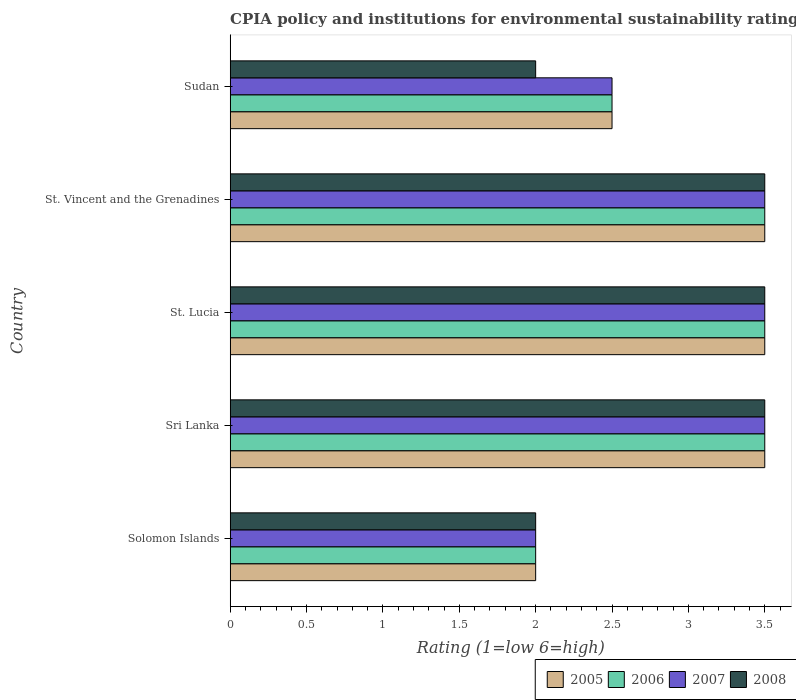How many different coloured bars are there?
Offer a terse response. 4. How many groups of bars are there?
Make the answer very short. 5. Are the number of bars on each tick of the Y-axis equal?
Ensure brevity in your answer.  Yes. How many bars are there on the 2nd tick from the top?
Keep it short and to the point. 4. What is the label of the 3rd group of bars from the top?
Your answer should be very brief. St. Lucia. In how many cases, is the number of bars for a given country not equal to the number of legend labels?
Your response must be concise. 0. What is the CPIA rating in 2007 in Sri Lanka?
Make the answer very short. 3.5. Across all countries, what is the minimum CPIA rating in 2005?
Your answer should be very brief. 2. In which country was the CPIA rating in 2005 maximum?
Provide a short and direct response. Sri Lanka. In which country was the CPIA rating in 2006 minimum?
Provide a succinct answer. Solomon Islands. What is the total CPIA rating in 2008 in the graph?
Provide a short and direct response. 14.5. What is the difference between the CPIA rating in 2007 in Sri Lanka and that in St. Lucia?
Keep it short and to the point. 0. What is the difference between the CPIA rating in 2008 in St. Lucia and the CPIA rating in 2006 in Sri Lanka?
Ensure brevity in your answer.  0. What is the difference between the CPIA rating in 2007 and CPIA rating in 2008 in Sri Lanka?
Give a very brief answer. 0. In how many countries, is the CPIA rating in 2005 greater than 3 ?
Make the answer very short. 3. Is the CPIA rating in 2005 in Sri Lanka less than that in Sudan?
Your answer should be compact. No. What is the difference between the highest and the second highest CPIA rating in 2008?
Your response must be concise. 0. What is the difference between the highest and the lowest CPIA rating in 2008?
Provide a succinct answer. 1.5. Is the sum of the CPIA rating in 2006 in Solomon Islands and Sri Lanka greater than the maximum CPIA rating in 2008 across all countries?
Give a very brief answer. Yes. Is it the case that in every country, the sum of the CPIA rating in 2005 and CPIA rating in 2008 is greater than the sum of CPIA rating in 2006 and CPIA rating in 2007?
Keep it short and to the point. No. What does the 2nd bar from the top in Sri Lanka represents?
Ensure brevity in your answer.  2007. What does the 4th bar from the bottom in St. Vincent and the Grenadines represents?
Offer a very short reply. 2008. Is it the case that in every country, the sum of the CPIA rating in 2008 and CPIA rating in 2006 is greater than the CPIA rating in 2007?
Give a very brief answer. Yes. How many bars are there?
Provide a succinct answer. 20. Are all the bars in the graph horizontal?
Make the answer very short. Yes. What is the difference between two consecutive major ticks on the X-axis?
Give a very brief answer. 0.5. Does the graph contain any zero values?
Your answer should be very brief. No. Where does the legend appear in the graph?
Offer a very short reply. Bottom right. How many legend labels are there?
Provide a succinct answer. 4. What is the title of the graph?
Ensure brevity in your answer.  CPIA policy and institutions for environmental sustainability rating. What is the label or title of the X-axis?
Make the answer very short. Rating (1=low 6=high). What is the Rating (1=low 6=high) in 2006 in Solomon Islands?
Make the answer very short. 2. What is the Rating (1=low 6=high) in 2005 in Sri Lanka?
Offer a very short reply. 3.5. What is the Rating (1=low 6=high) in 2006 in Sri Lanka?
Your answer should be very brief. 3.5. What is the Rating (1=low 6=high) of 2005 in St. Vincent and the Grenadines?
Offer a terse response. 3.5. What is the Rating (1=low 6=high) of 2006 in St. Vincent and the Grenadines?
Give a very brief answer. 3.5. What is the Rating (1=low 6=high) in 2005 in Sudan?
Provide a short and direct response. 2.5. What is the Rating (1=low 6=high) in 2006 in Sudan?
Offer a terse response. 2.5. What is the Rating (1=low 6=high) of 2007 in Sudan?
Your response must be concise. 2.5. What is the Rating (1=low 6=high) in 2008 in Sudan?
Offer a very short reply. 2. Across all countries, what is the maximum Rating (1=low 6=high) of 2006?
Give a very brief answer. 3.5. Across all countries, what is the maximum Rating (1=low 6=high) in 2007?
Offer a very short reply. 3.5. Across all countries, what is the maximum Rating (1=low 6=high) in 2008?
Provide a succinct answer. 3.5. Across all countries, what is the minimum Rating (1=low 6=high) in 2005?
Your answer should be very brief. 2. What is the total Rating (1=low 6=high) in 2007 in the graph?
Make the answer very short. 15. What is the difference between the Rating (1=low 6=high) of 2005 in Solomon Islands and that in Sri Lanka?
Your answer should be compact. -1.5. What is the difference between the Rating (1=low 6=high) in 2006 in Solomon Islands and that in Sri Lanka?
Offer a very short reply. -1.5. What is the difference between the Rating (1=low 6=high) in 2008 in Solomon Islands and that in St. Lucia?
Your answer should be very brief. -1.5. What is the difference between the Rating (1=low 6=high) in 2005 in Solomon Islands and that in St. Vincent and the Grenadines?
Give a very brief answer. -1.5. What is the difference between the Rating (1=low 6=high) in 2007 in Solomon Islands and that in St. Vincent and the Grenadines?
Give a very brief answer. -1.5. What is the difference between the Rating (1=low 6=high) in 2008 in Solomon Islands and that in St. Vincent and the Grenadines?
Offer a very short reply. -1.5. What is the difference between the Rating (1=low 6=high) of 2008 in Solomon Islands and that in Sudan?
Provide a succinct answer. 0. What is the difference between the Rating (1=low 6=high) of 2005 in Sri Lanka and that in St. Lucia?
Give a very brief answer. 0. What is the difference between the Rating (1=low 6=high) in 2007 in Sri Lanka and that in St. Lucia?
Keep it short and to the point. 0. What is the difference between the Rating (1=low 6=high) of 2007 in Sri Lanka and that in St. Vincent and the Grenadines?
Provide a succinct answer. 0. What is the difference between the Rating (1=low 6=high) of 2008 in Sri Lanka and that in St. Vincent and the Grenadines?
Your answer should be compact. 0. What is the difference between the Rating (1=low 6=high) of 2005 in Sri Lanka and that in Sudan?
Your answer should be compact. 1. What is the difference between the Rating (1=low 6=high) in 2006 in Sri Lanka and that in Sudan?
Provide a succinct answer. 1. What is the difference between the Rating (1=low 6=high) in 2008 in Sri Lanka and that in Sudan?
Make the answer very short. 1.5. What is the difference between the Rating (1=low 6=high) of 2005 in St. Lucia and that in St. Vincent and the Grenadines?
Your response must be concise. 0. What is the difference between the Rating (1=low 6=high) of 2007 in St. Lucia and that in St. Vincent and the Grenadines?
Provide a short and direct response. 0. What is the difference between the Rating (1=low 6=high) of 2005 in St. Lucia and that in Sudan?
Ensure brevity in your answer.  1. What is the difference between the Rating (1=low 6=high) in 2006 in St. Vincent and the Grenadines and that in Sudan?
Make the answer very short. 1. What is the difference between the Rating (1=low 6=high) of 2005 in Solomon Islands and the Rating (1=low 6=high) of 2006 in Sri Lanka?
Your response must be concise. -1.5. What is the difference between the Rating (1=low 6=high) of 2006 in Solomon Islands and the Rating (1=low 6=high) of 2008 in Sri Lanka?
Offer a terse response. -1.5. What is the difference between the Rating (1=low 6=high) of 2005 in Solomon Islands and the Rating (1=low 6=high) of 2007 in St. Lucia?
Your response must be concise. -1.5. What is the difference between the Rating (1=low 6=high) in 2005 in Solomon Islands and the Rating (1=low 6=high) in 2008 in St. Lucia?
Provide a short and direct response. -1.5. What is the difference between the Rating (1=low 6=high) in 2007 in Solomon Islands and the Rating (1=low 6=high) in 2008 in St. Lucia?
Your answer should be very brief. -1.5. What is the difference between the Rating (1=low 6=high) in 2005 in Solomon Islands and the Rating (1=low 6=high) in 2006 in St. Vincent and the Grenadines?
Make the answer very short. -1.5. What is the difference between the Rating (1=low 6=high) of 2005 in Solomon Islands and the Rating (1=low 6=high) of 2007 in St. Vincent and the Grenadines?
Offer a very short reply. -1.5. What is the difference between the Rating (1=low 6=high) of 2006 in Solomon Islands and the Rating (1=low 6=high) of 2007 in St. Vincent and the Grenadines?
Your answer should be compact. -1.5. What is the difference between the Rating (1=low 6=high) in 2006 in Solomon Islands and the Rating (1=low 6=high) in 2007 in Sudan?
Make the answer very short. -0.5. What is the difference between the Rating (1=low 6=high) of 2007 in Solomon Islands and the Rating (1=low 6=high) of 2008 in Sudan?
Ensure brevity in your answer.  0. What is the difference between the Rating (1=low 6=high) of 2005 in Sri Lanka and the Rating (1=low 6=high) of 2006 in St. Lucia?
Provide a succinct answer. 0. What is the difference between the Rating (1=low 6=high) of 2006 in Sri Lanka and the Rating (1=low 6=high) of 2008 in St. Lucia?
Provide a short and direct response. 0. What is the difference between the Rating (1=low 6=high) in 2007 in Sri Lanka and the Rating (1=low 6=high) in 2008 in St. Lucia?
Ensure brevity in your answer.  0. What is the difference between the Rating (1=low 6=high) of 2005 in Sri Lanka and the Rating (1=low 6=high) of 2006 in St. Vincent and the Grenadines?
Offer a very short reply. 0. What is the difference between the Rating (1=low 6=high) of 2005 in Sri Lanka and the Rating (1=low 6=high) of 2007 in St. Vincent and the Grenadines?
Provide a short and direct response. 0. What is the difference between the Rating (1=low 6=high) of 2005 in Sri Lanka and the Rating (1=low 6=high) of 2008 in St. Vincent and the Grenadines?
Provide a succinct answer. 0. What is the difference between the Rating (1=low 6=high) in 2006 in Sri Lanka and the Rating (1=low 6=high) in 2007 in St. Vincent and the Grenadines?
Offer a very short reply. 0. What is the difference between the Rating (1=low 6=high) of 2007 in Sri Lanka and the Rating (1=low 6=high) of 2008 in St. Vincent and the Grenadines?
Ensure brevity in your answer.  0. What is the difference between the Rating (1=low 6=high) in 2005 in Sri Lanka and the Rating (1=low 6=high) in 2008 in Sudan?
Provide a short and direct response. 1.5. What is the difference between the Rating (1=low 6=high) in 2005 in St. Lucia and the Rating (1=low 6=high) in 2006 in St. Vincent and the Grenadines?
Your answer should be very brief. 0. What is the difference between the Rating (1=low 6=high) in 2006 in St. Lucia and the Rating (1=low 6=high) in 2007 in St. Vincent and the Grenadines?
Offer a terse response. 0. What is the difference between the Rating (1=low 6=high) of 2006 in St. Lucia and the Rating (1=low 6=high) of 2007 in Sudan?
Offer a very short reply. 1. What is the difference between the Rating (1=low 6=high) in 2005 in St. Vincent and the Grenadines and the Rating (1=low 6=high) in 2007 in Sudan?
Keep it short and to the point. 1. What is the difference between the Rating (1=low 6=high) of 2005 in St. Vincent and the Grenadines and the Rating (1=low 6=high) of 2008 in Sudan?
Provide a succinct answer. 1.5. What is the average Rating (1=low 6=high) in 2006 per country?
Give a very brief answer. 3. What is the average Rating (1=low 6=high) of 2007 per country?
Your answer should be compact. 3. What is the difference between the Rating (1=low 6=high) in 2005 and Rating (1=low 6=high) in 2006 in Solomon Islands?
Make the answer very short. 0. What is the difference between the Rating (1=low 6=high) of 2005 and Rating (1=low 6=high) of 2007 in Solomon Islands?
Make the answer very short. 0. What is the difference between the Rating (1=low 6=high) in 2005 and Rating (1=low 6=high) in 2008 in Solomon Islands?
Keep it short and to the point. 0. What is the difference between the Rating (1=low 6=high) in 2005 and Rating (1=low 6=high) in 2007 in Sri Lanka?
Your answer should be compact. 0. What is the difference between the Rating (1=low 6=high) of 2005 and Rating (1=low 6=high) of 2008 in Sri Lanka?
Make the answer very short. 0. What is the difference between the Rating (1=low 6=high) of 2006 and Rating (1=low 6=high) of 2007 in Sri Lanka?
Make the answer very short. 0. What is the difference between the Rating (1=low 6=high) of 2006 and Rating (1=low 6=high) of 2008 in Sri Lanka?
Your answer should be very brief. 0. What is the difference between the Rating (1=low 6=high) in 2007 and Rating (1=low 6=high) in 2008 in Sri Lanka?
Offer a terse response. 0. What is the difference between the Rating (1=low 6=high) of 2005 and Rating (1=low 6=high) of 2006 in St. Lucia?
Your answer should be compact. 0. What is the difference between the Rating (1=low 6=high) of 2006 and Rating (1=low 6=high) of 2007 in St. Lucia?
Provide a succinct answer. 0. What is the difference between the Rating (1=low 6=high) of 2006 and Rating (1=low 6=high) of 2008 in St. Lucia?
Offer a very short reply. 0. What is the difference between the Rating (1=low 6=high) in 2007 and Rating (1=low 6=high) in 2008 in St. Lucia?
Ensure brevity in your answer.  0. What is the difference between the Rating (1=low 6=high) of 2005 and Rating (1=low 6=high) of 2006 in St. Vincent and the Grenadines?
Offer a very short reply. 0. What is the difference between the Rating (1=low 6=high) of 2005 and Rating (1=low 6=high) of 2007 in St. Vincent and the Grenadines?
Offer a very short reply. 0. What is the difference between the Rating (1=low 6=high) of 2006 and Rating (1=low 6=high) of 2008 in St. Vincent and the Grenadines?
Keep it short and to the point. 0. What is the difference between the Rating (1=low 6=high) of 2005 and Rating (1=low 6=high) of 2006 in Sudan?
Make the answer very short. 0. What is the difference between the Rating (1=low 6=high) in 2005 and Rating (1=low 6=high) in 2008 in Sudan?
Offer a terse response. 0.5. What is the difference between the Rating (1=low 6=high) in 2006 and Rating (1=low 6=high) in 2008 in Sudan?
Offer a very short reply. 0.5. What is the ratio of the Rating (1=low 6=high) in 2005 in Solomon Islands to that in Sri Lanka?
Ensure brevity in your answer.  0.57. What is the ratio of the Rating (1=low 6=high) of 2007 in Solomon Islands to that in Sri Lanka?
Your response must be concise. 0.57. What is the ratio of the Rating (1=low 6=high) in 2008 in Solomon Islands to that in Sri Lanka?
Offer a very short reply. 0.57. What is the ratio of the Rating (1=low 6=high) in 2007 in Solomon Islands to that in St. Lucia?
Provide a short and direct response. 0.57. What is the ratio of the Rating (1=low 6=high) in 2008 in Solomon Islands to that in St. Vincent and the Grenadines?
Your response must be concise. 0.57. What is the ratio of the Rating (1=low 6=high) in 2005 in Solomon Islands to that in Sudan?
Your answer should be very brief. 0.8. What is the ratio of the Rating (1=low 6=high) of 2007 in Solomon Islands to that in Sudan?
Your answer should be very brief. 0.8. What is the ratio of the Rating (1=low 6=high) in 2008 in Sri Lanka to that in St. Lucia?
Offer a terse response. 1. What is the ratio of the Rating (1=low 6=high) of 2005 in Sri Lanka to that in St. Vincent and the Grenadines?
Your answer should be compact. 1. What is the ratio of the Rating (1=low 6=high) in 2006 in Sri Lanka to that in St. Vincent and the Grenadines?
Ensure brevity in your answer.  1. What is the ratio of the Rating (1=low 6=high) in 2007 in Sri Lanka to that in St. Vincent and the Grenadines?
Your response must be concise. 1. What is the ratio of the Rating (1=low 6=high) in 2006 in Sri Lanka to that in Sudan?
Keep it short and to the point. 1.4. What is the ratio of the Rating (1=low 6=high) of 2007 in Sri Lanka to that in Sudan?
Your answer should be very brief. 1.4. What is the ratio of the Rating (1=low 6=high) of 2007 in St. Lucia to that in St. Vincent and the Grenadines?
Provide a succinct answer. 1. What is the ratio of the Rating (1=low 6=high) of 2008 in St. Lucia to that in St. Vincent and the Grenadines?
Provide a short and direct response. 1. What is the ratio of the Rating (1=low 6=high) of 2005 in St. Lucia to that in Sudan?
Offer a very short reply. 1.4. What is the ratio of the Rating (1=low 6=high) in 2006 in St. Lucia to that in Sudan?
Provide a short and direct response. 1.4. What is the ratio of the Rating (1=low 6=high) of 2007 in St. Lucia to that in Sudan?
Make the answer very short. 1.4. What is the ratio of the Rating (1=low 6=high) in 2006 in St. Vincent and the Grenadines to that in Sudan?
Provide a succinct answer. 1.4. What is the ratio of the Rating (1=low 6=high) of 2008 in St. Vincent and the Grenadines to that in Sudan?
Provide a short and direct response. 1.75. What is the difference between the highest and the lowest Rating (1=low 6=high) in 2005?
Provide a short and direct response. 1.5. 